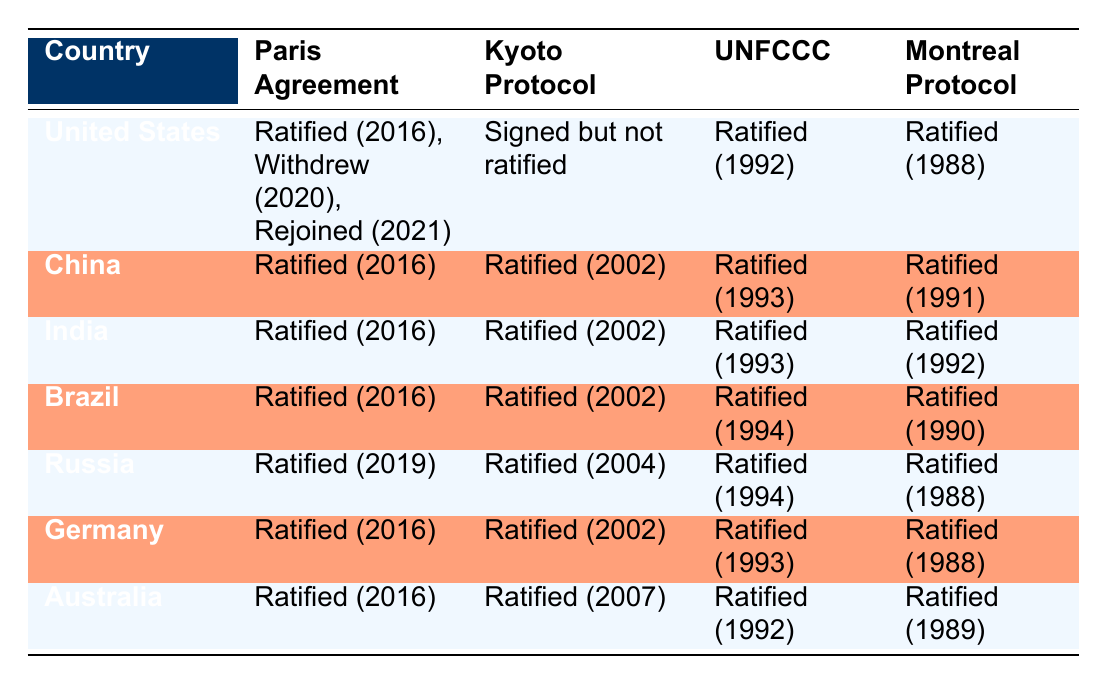What is the ratification status of the Paris Agreement for the United States? The table states that the United States ratified the Paris Agreement in 2016, withdrew in 2020, and then rejoined in 2021. This is a direct retrieval from the "Paris Agreement" column for the United States.
Answer: Ratified (2016), Withdrew (2020), Rejoined (2021) Which countries ratified the Kyoto Protocol in 2002? Looking in the "Kyoto Protocol" column, we see that China, India, Brazil, and Germany all ratified the Kyoto Protocol in 2002. This is a direct retrieval of data across multiple rows.
Answer: China, India, Brazil, Germany Did Australia ratify the Montreal Protocol? The table shows that Australia has ratified the Montreal Protocol, which confirms the fact directly. This is a simple yes or no question based on the table.
Answer: Yes How many countries have ratified the UNFCCC in 1992? Inspecting the "UNFCCC" column, the countries that ratified in 1992 include the United States, Australia, and Germany. So there are three countries. Counting these directly gives the answer.
Answer: 3 Which country is the last to ratify the Paris Agreement? By reviewing the "Paris Agreement" column, we see that Russia ratified it in 2019, which is the latest date listed in the table. This requires filtering to find the maximum date among the entries.
Answer: Russia Is it true that China and India ratified both the Kyoto Protocol and the Paris Agreement? The "Kyoto Protocol" column shows that both China and India ratified it in 2002, and both are listed as ratifying the Paris Agreement in 2016 in the "Paris Agreement" column. This involves checking both columns for each country to confirm the fact.
Answer: Yes Which country has a status of "Signed but not ratified" for the Kyoto Protocol? The table indicates that the United States has a "Signed but not ratified" status for the Kyoto Protocol, which is a straightforward lookup in the table.
Answer: United States What is the earliest date of ratification for the Montreal Protocol among these countries? In the "Montreal Protocol" column, Australia ratified it in 1989, while China ratified it in 1991, and others ratified it even later or in the same year. This requires comparing all listed dates to find the earliest one.
Answer: 1988 